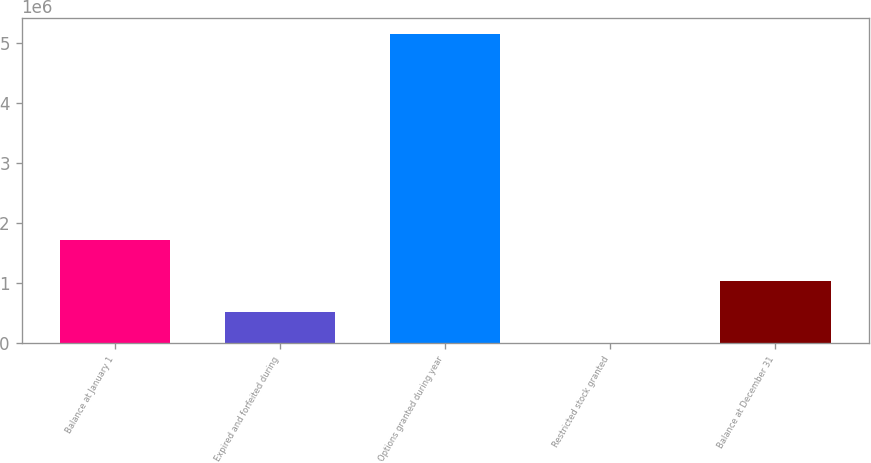Convert chart. <chart><loc_0><loc_0><loc_500><loc_500><bar_chart><fcel>Balance at January 1<fcel>Expired and forfeited during<fcel>Options granted during year<fcel>Restricted stock granted<fcel>Balance at December 31<nl><fcel>1.71692e+06<fcel>516314<fcel>5.16312e+06<fcel>2.04<fcel>1.03263e+06<nl></chart> 